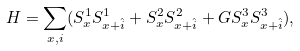Convert formula to latex. <formula><loc_0><loc_0><loc_500><loc_500>H = \sum _ { x , i } ( S _ { x } ^ { 1 } S _ { x + \hat { i } } ^ { 1 } + S _ { x } ^ { 2 } S _ { x + \hat { i } } ^ { 2 } + G S _ { x } ^ { 3 } S _ { x + \hat { i } } ^ { 3 } ) ,</formula> 